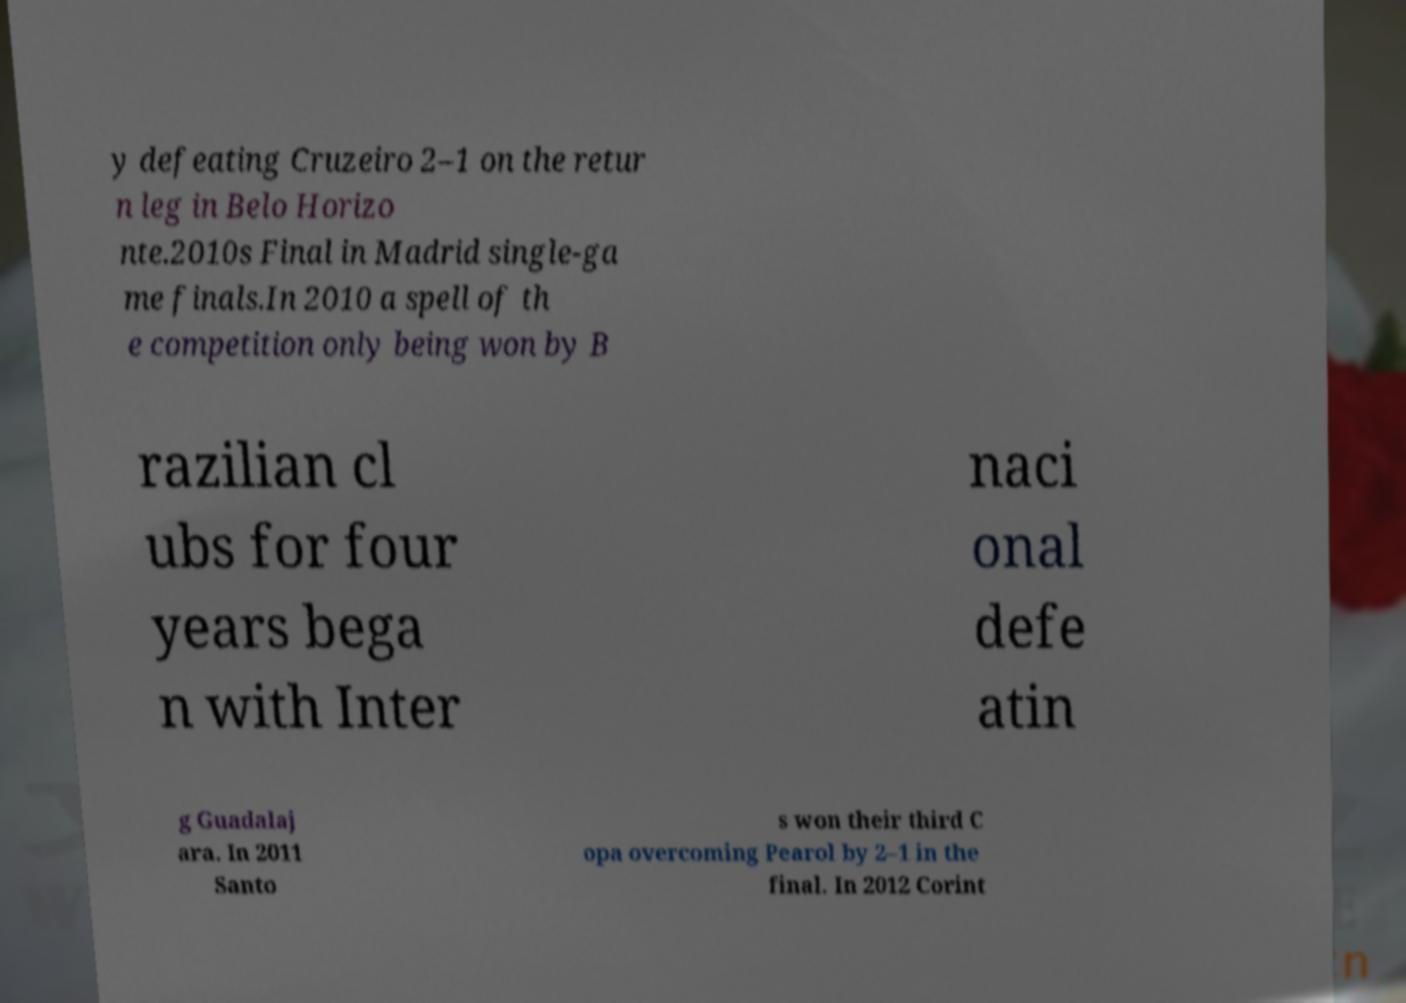Please read and relay the text visible in this image. What does it say? y defeating Cruzeiro 2–1 on the retur n leg in Belo Horizo nte.2010s Final in Madrid single-ga me finals.In 2010 a spell of th e competition only being won by B razilian cl ubs for four years bega n with Inter naci onal defe atin g Guadalaj ara. In 2011 Santo s won their third C opa overcoming Pearol by 2–1 in the final. In 2012 Corint 